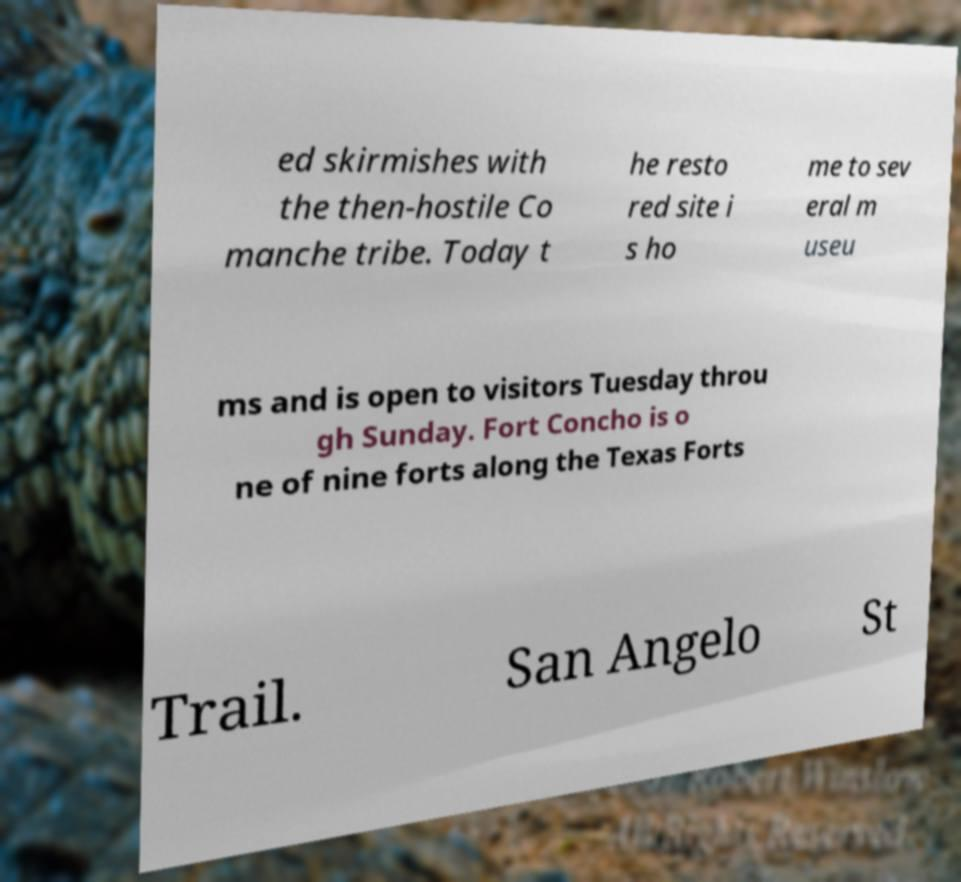What messages or text are displayed in this image? I need them in a readable, typed format. ed skirmishes with the then-hostile Co manche tribe. Today t he resto red site i s ho me to sev eral m useu ms and is open to visitors Tuesday throu gh Sunday. Fort Concho is o ne of nine forts along the Texas Forts Trail. San Angelo St 